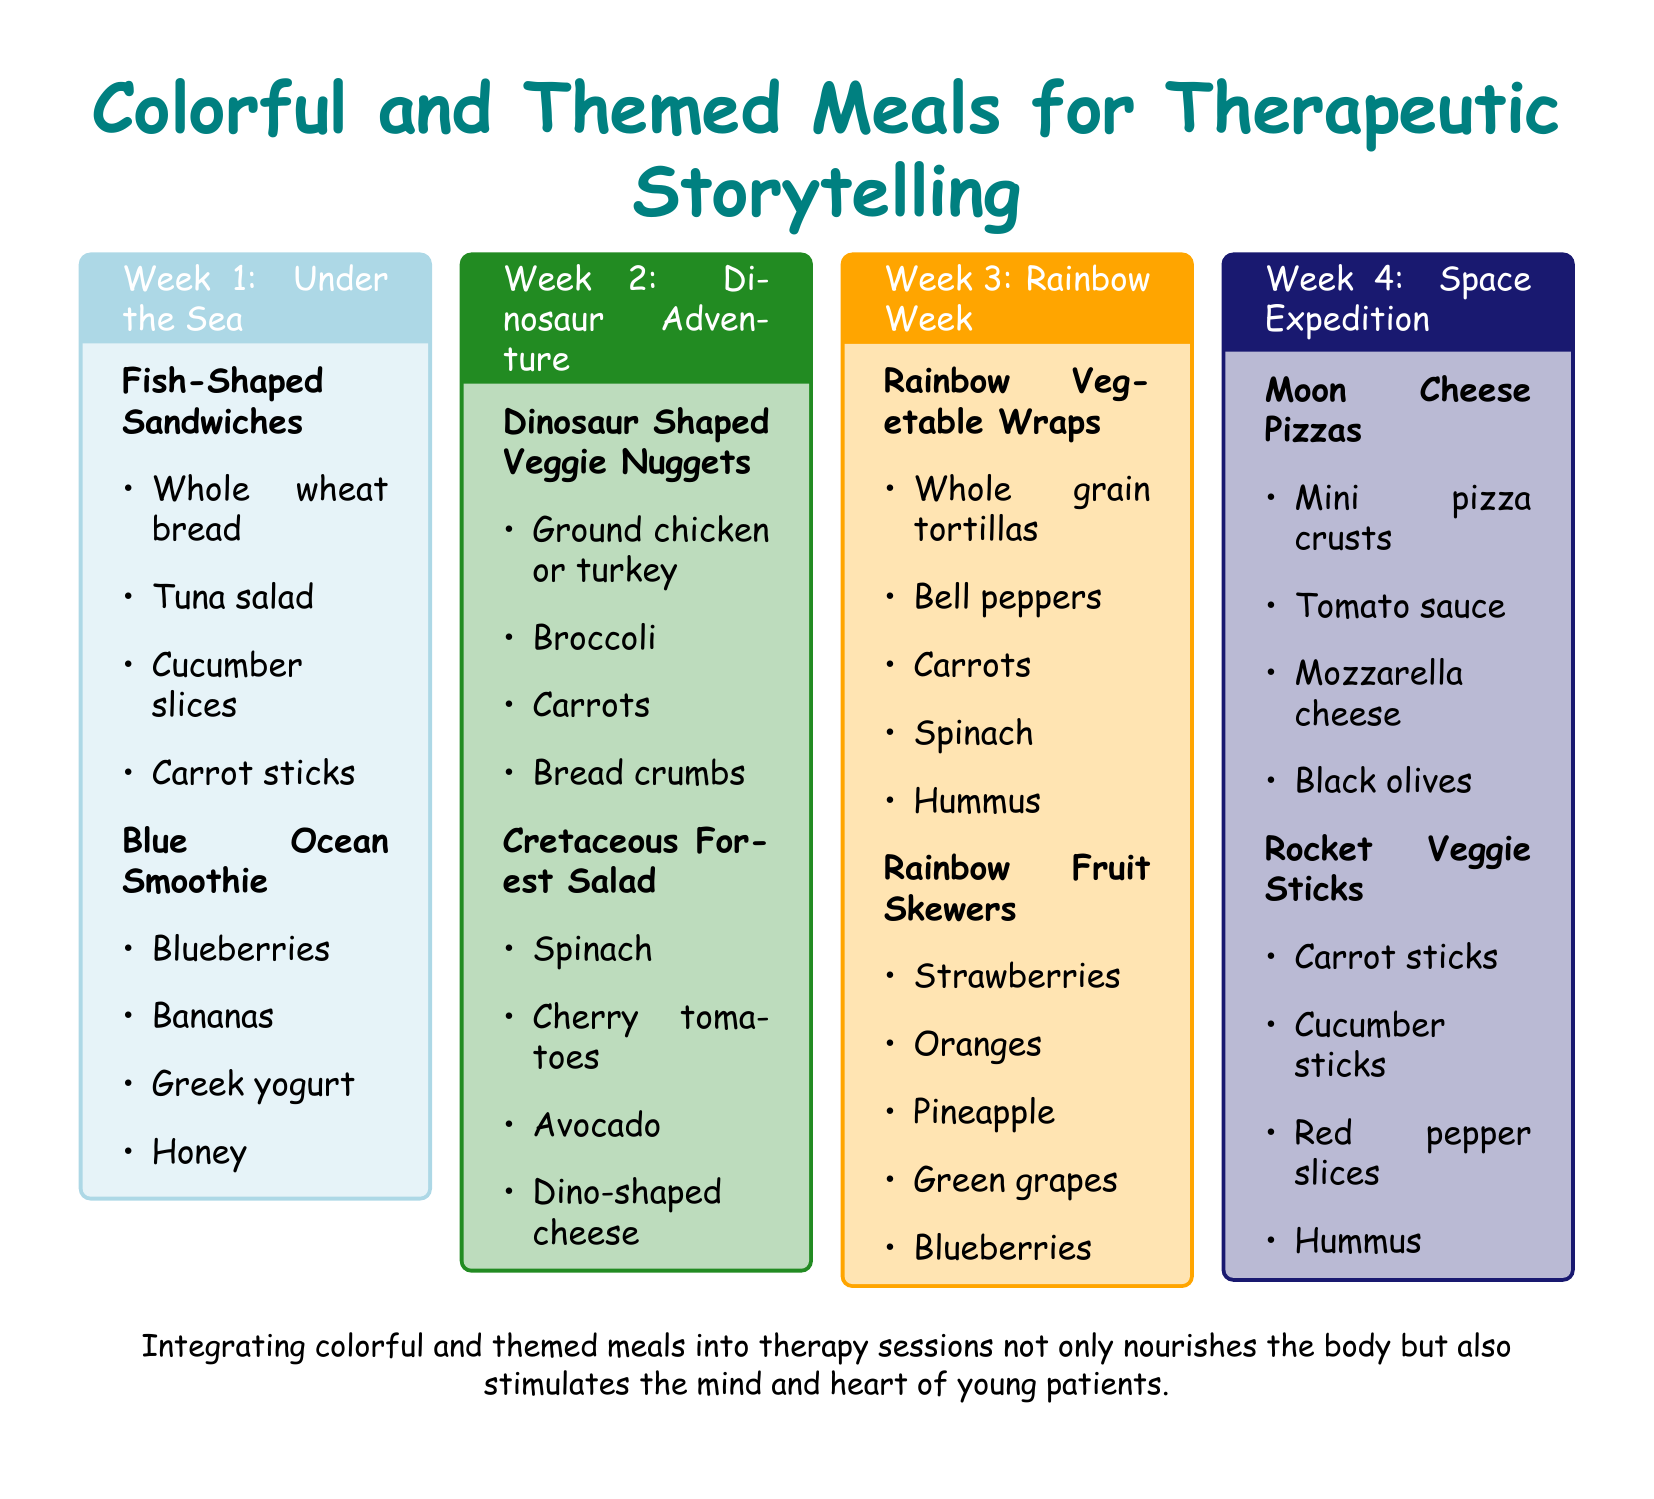What is the title of Week 1's theme? The title of Week 1 is "Under the Sea."
Answer: Under the Sea How many meals are suggested for each week? Each week has two meals suggested.
Answer: Two meals What ingredient is used in the Blue Ocean Smoothie? The Blue Ocean Smoothie includes blueberries, which is highlighted in the recipe.
Answer: Blueberries What shape are the veggie nuggets in Week 2? The veggie nuggets are shaped like dinosaurs, as stated under the meal title.
Answer: Dinosaur Which week features Rainbow Fruit Skewers? The Rainbow Fruit Skewers are featured in Week 3.
Answer: Week 3 What color is the background of the tcolorbox for Week 4? The background for Week 4 is colored with a space-themed color, specifically described as space color.
Answer: Space Which meal includes dino-shaped cheese? The meal that includes dino-shaped cheese is the Cretaceous Forest Salad.
Answer: Cretaceous Forest Salad What type of cheese is used on the Moon Cheese Pizzas? The type of cheese used on the Moon Cheese Pizzas is mozzarella.
Answer: Mozzarella How are the veggie sticks served in Week 4? The veggie sticks are served with hummus, as indicated in the recipe.
Answer: Hummus 